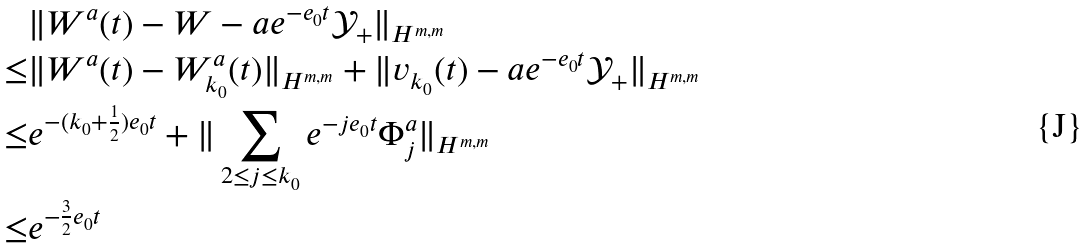<formula> <loc_0><loc_0><loc_500><loc_500>& \| W ^ { a } ( t ) - W - a e ^ { - e _ { 0 } t } \mathcal { Y } _ { + } \| _ { H ^ { m , m } } \\ \leq & \| W ^ { a } ( t ) - W _ { k _ { 0 } } ^ { a } ( t ) \| _ { H ^ { m , m } } + \| v _ { k _ { 0 } } ( t ) - a e ^ { - e _ { 0 } t } \mathcal { Y } _ { + } \| _ { H ^ { m , m } } \\ \leq & e ^ { - ( k _ { 0 } + \frac { 1 } { 2 } ) e _ { 0 } t } + \| \sum _ { 2 \leq j \leq k _ { 0 } } e ^ { - j e _ { 0 } t } \Phi _ { j } ^ { a } \| _ { H ^ { m , m } } \\ \leq & e ^ { - \frac { 3 } { 2 } e _ { 0 } t }</formula> 